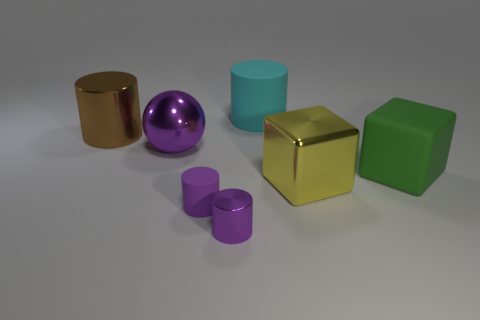Are there an equal number of matte objects that are in front of the tiny rubber thing and metallic cubes?
Make the answer very short. No. What is the size of the matte cylinder that is left of the cyan rubber cylinder?
Your response must be concise. Small. What number of tiny purple metallic objects are the same shape as the large cyan thing?
Your answer should be very brief. 1. There is a purple thing that is both in front of the yellow block and on the left side of the tiny metallic object; what is its material?
Provide a succinct answer. Rubber. Is the material of the green thing the same as the ball?
Give a very brief answer. No. How many big green matte cubes are there?
Ensure brevity in your answer.  1. There is a small cylinder to the left of the purple shiny thing in front of the shiny sphere behind the green thing; what is its color?
Offer a very short reply. Purple. Is the color of the big metal ball the same as the matte block?
Make the answer very short. No. How many big shiny objects are both in front of the brown metallic cylinder and to the left of the tiny purple metal cylinder?
Make the answer very short. 1. What number of metallic things are either spheres or big cyan objects?
Give a very brief answer. 1. 